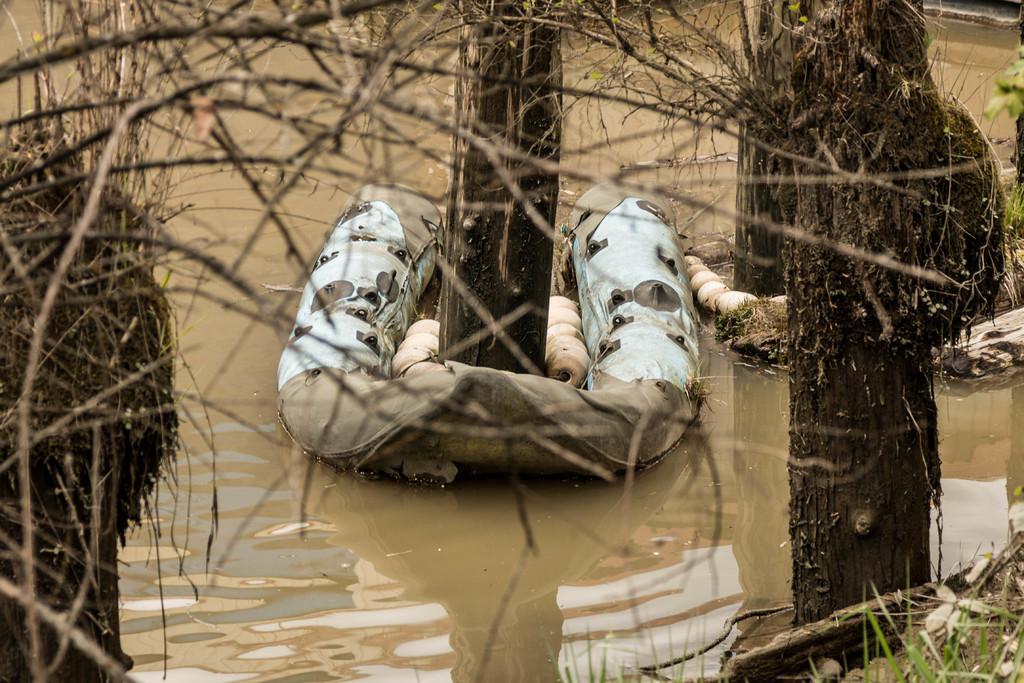In one or two sentences, can you explain what this image depicts? In this picture there are trees on the right and left side of the image and there is water around the area of the image. 